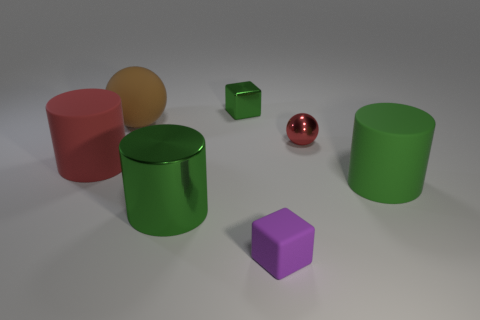What is the lighting setup like in this scene? The lighting setup in this scene seems to be diffuse with soft shadows, suggesting that the light source is not directly visible and is likely coming from above, simulating an overcast day or a room with a soft overhead light. The absence of harsh shadows or strong specular highlights on the objects indicates that there is no strong, direct lighting in play. 